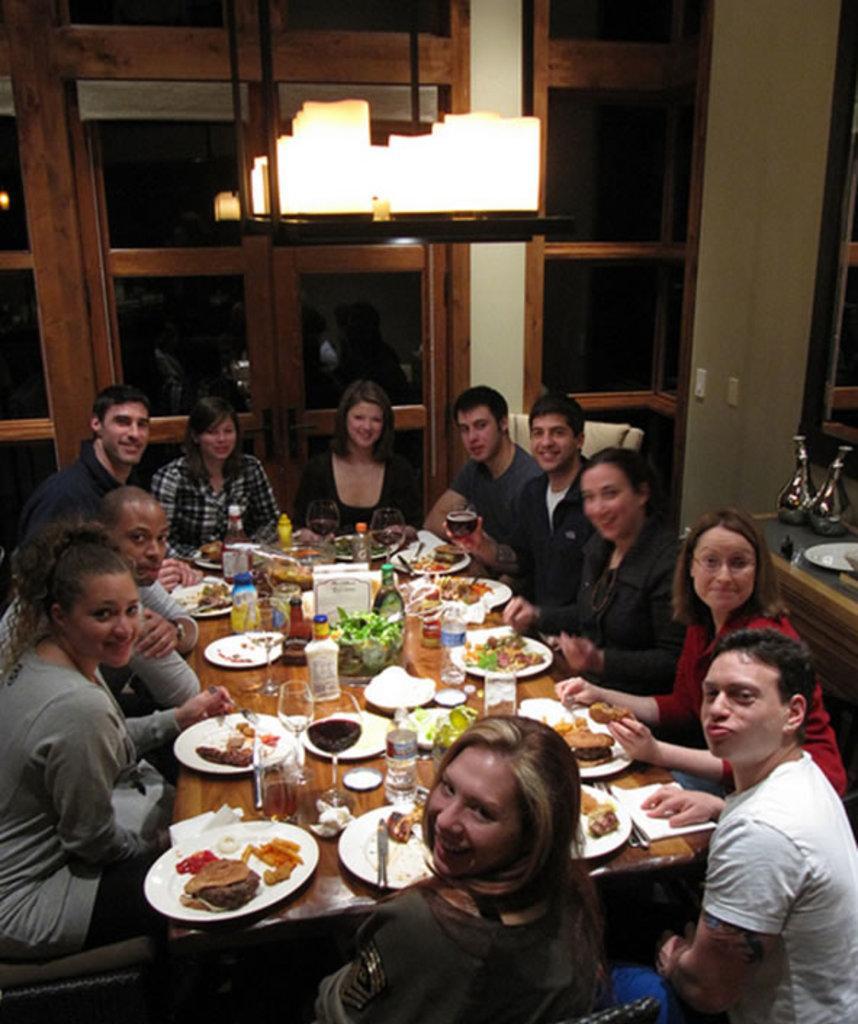Could you give a brief overview of what you see in this image? As we can see in the image there are few people sitting on chairs and there is a table over here. On table there are glasses and plates. 